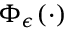Convert formula to latex. <formula><loc_0><loc_0><loc_500><loc_500>\Phi _ { \epsilon } ( \cdot )</formula> 